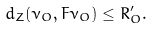Convert formula to latex. <formula><loc_0><loc_0><loc_500><loc_500>d _ { Z } ( \nu _ { O } , F \nu _ { O } ) \leq R _ { O } ^ { \prime } .</formula> 